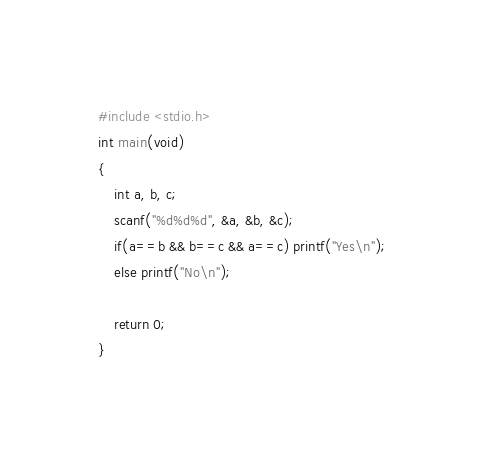Convert code to text. <code><loc_0><loc_0><loc_500><loc_500><_C_>#include <stdio.h>
int main(void)
{
    int a, b, c;
    scanf("%d%d%d", &a, &b, &c);
    if(a==b && b==c && a==c) printf("Yes\n");
    else printf("No\n");

    return 0;
}
</code> 